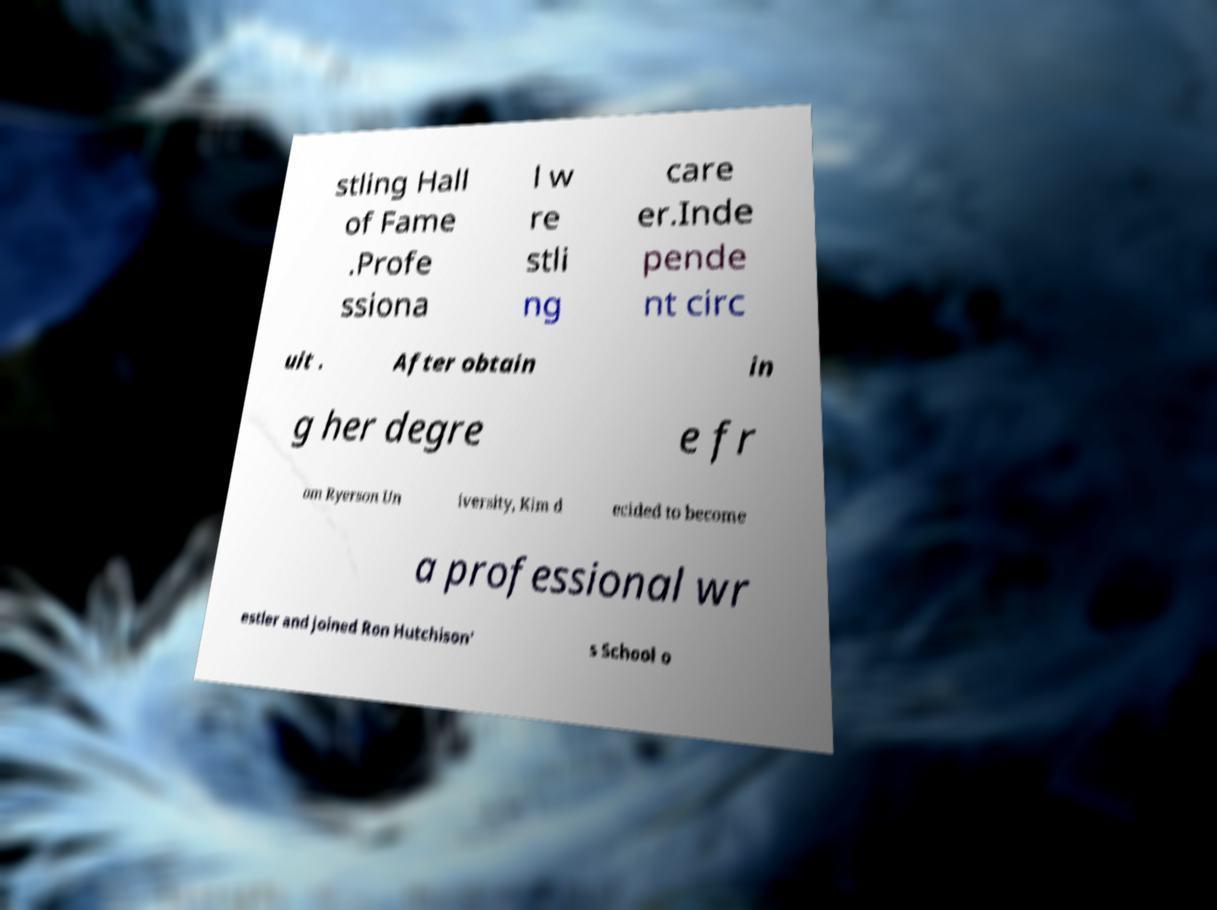For documentation purposes, I need the text within this image transcribed. Could you provide that? stling Hall of Fame .Profe ssiona l w re stli ng care er.Inde pende nt circ uit . After obtain in g her degre e fr om Ryerson Un iversity, Kim d ecided to become a professional wr estler and joined Ron Hutchison' s School o 